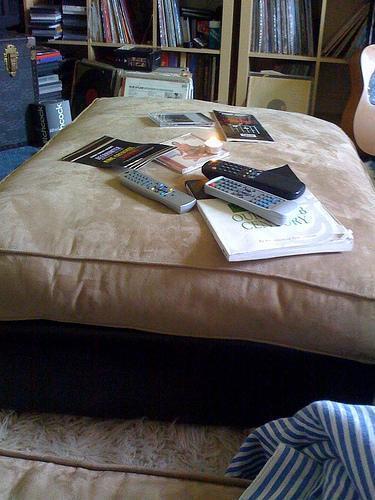How many remotes are on the bed?
Give a very brief answer. 3. How many books can be seen?
Give a very brief answer. 3. How many people are performing a trick on a skateboard?
Give a very brief answer. 0. 